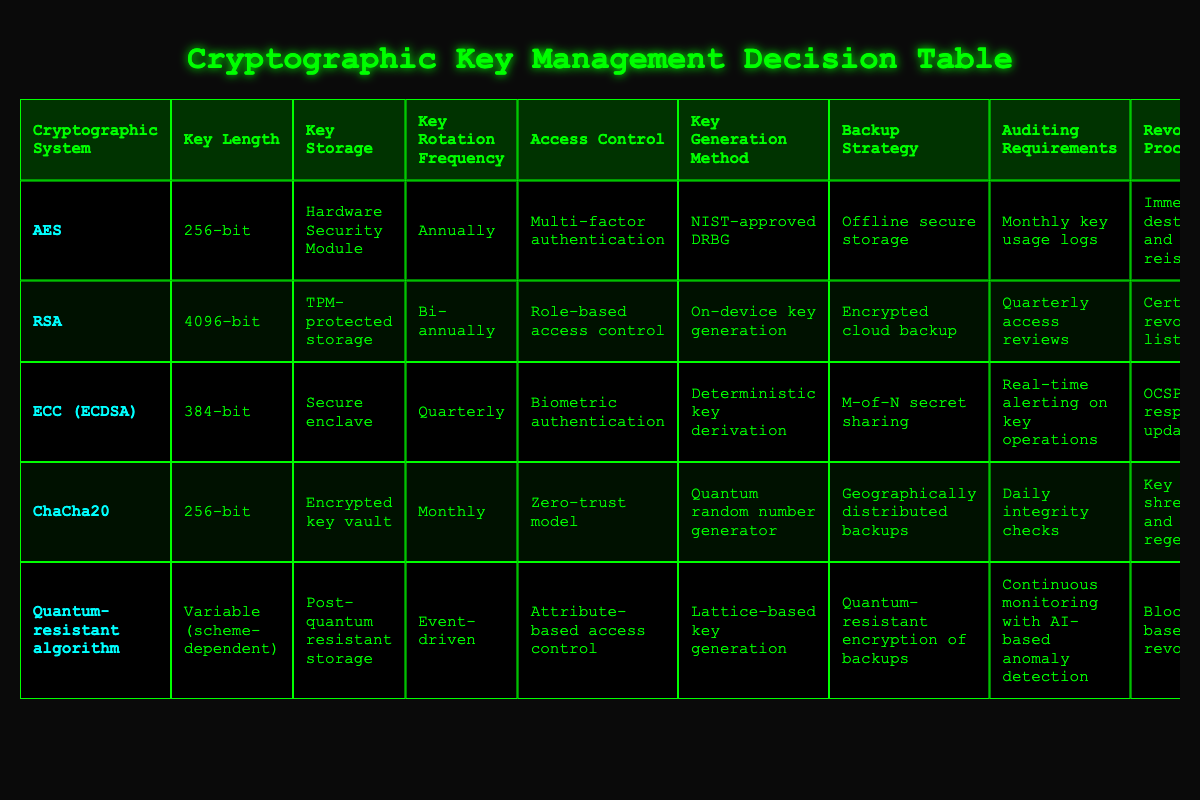What is the key length for the RSA cryptographic system? From the table, we can see that the RSA system has a key length of "4096-bit" listed in the Key Length column.
Answer: 4096-bit Which cryptographic system uses a hardware security module for key storage? The table indicates that the AES system is associated with "Hardware Security Module" in the Key Storage column.
Answer: AES How often should keys be rotated for the ChaCha20 system? According to the table, the ChaCha20 cryptographic system has a key rotation frequency of "Monthly" recorded in the Key Rotation Frequency column.
Answer: Monthly Is the access control for ECC (ECDSA) based on role-based access control? By checking the access control measures listed in the table for ECC (ECDSA), we find it states "Biometric authentication," hence it is not role-based access control.
Answer: No What are the auditing requirements for the quantum-resistant algorithm? The quantum-resistant algorithm has "Continuous monitoring with AI-based anomaly detection" as its auditing requirement, as detailed in the Auditing Requirements column of the table.
Answer: Continuous monitoring with AI-based anomaly detection Which cryptographic system has the highest key length, and what is it? By analyzing the Key Length column, the highest value is "4096-bit," corresponding to the RSA cryptographic system. Thus, RSA has the highest key length.
Answer: RSA, 4096-bit Does the backup strategy for ECC (ECDSA) involve M-of-N secret sharing? From the table, we observe that the backup strategy for ECC (ECDSA) is defined as "M-of-N secret sharing," confirming that this is indeed true.
Answer: Yes What is the difference in key rotation frequency between AES and ChaCha20? AES has a key rotation frequency of "Annually" while ChaCha20 has a frequency of "Monthly." To find the difference, we note that "Annually" is longer than "Monthly" or 12 months, hence ChaCha20 has a more frequent rotation schedule.
Answer: 11 months (more frequent for ChaCha20) How does the backup strategy of the quantum-resistant algorithm compare to that of RSA? The backup strategy for the quantum-resistant algorithm is "Quantum-resistant encryption of backups," while RSA uses "Encrypted cloud backup." These strategies indicate they are both secure but utilize different methods for backup security.
Answer: Different methods but secure 